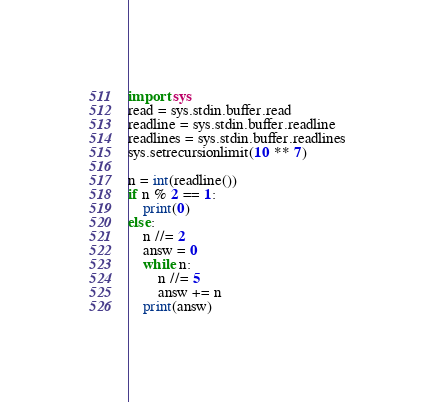<code> <loc_0><loc_0><loc_500><loc_500><_Python_>import sys
read = sys.stdin.buffer.read
readline = sys.stdin.buffer.readline
readlines = sys.stdin.buffer.readlines
sys.setrecursionlimit(10 ** 7)
 
n = int(readline())
if n % 2 == 1:
    print(0)
else:
    n //= 2
    answ = 0
    while n:
        n //= 5
        answ += n
    print(answ)</code> 